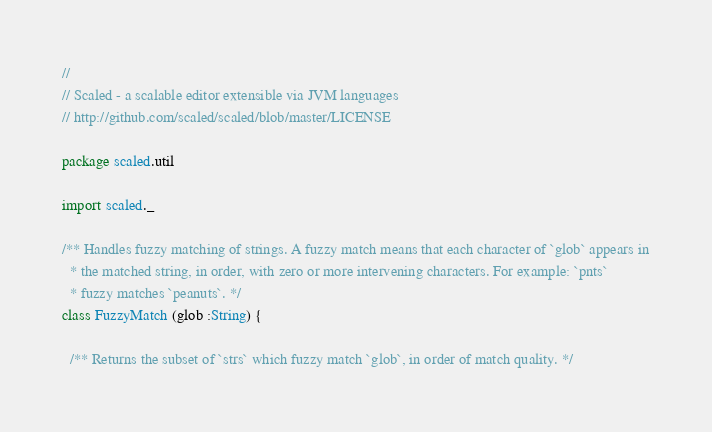Convert code to text. <code><loc_0><loc_0><loc_500><loc_500><_Scala_>//
// Scaled - a scalable editor extensible via JVM languages
// http://github.com/scaled/scaled/blob/master/LICENSE

package scaled.util

import scaled._

/** Handles fuzzy matching of strings. A fuzzy match means that each character of `glob` appears in
  * the matched string, in order, with zero or more intervening characters. For example: `pnts`
  * fuzzy matches `peanuts`. */
class FuzzyMatch (glob :String) {

  /** Returns the subset of `strs` which fuzzy match `glob`, in order of match quality. */</code> 